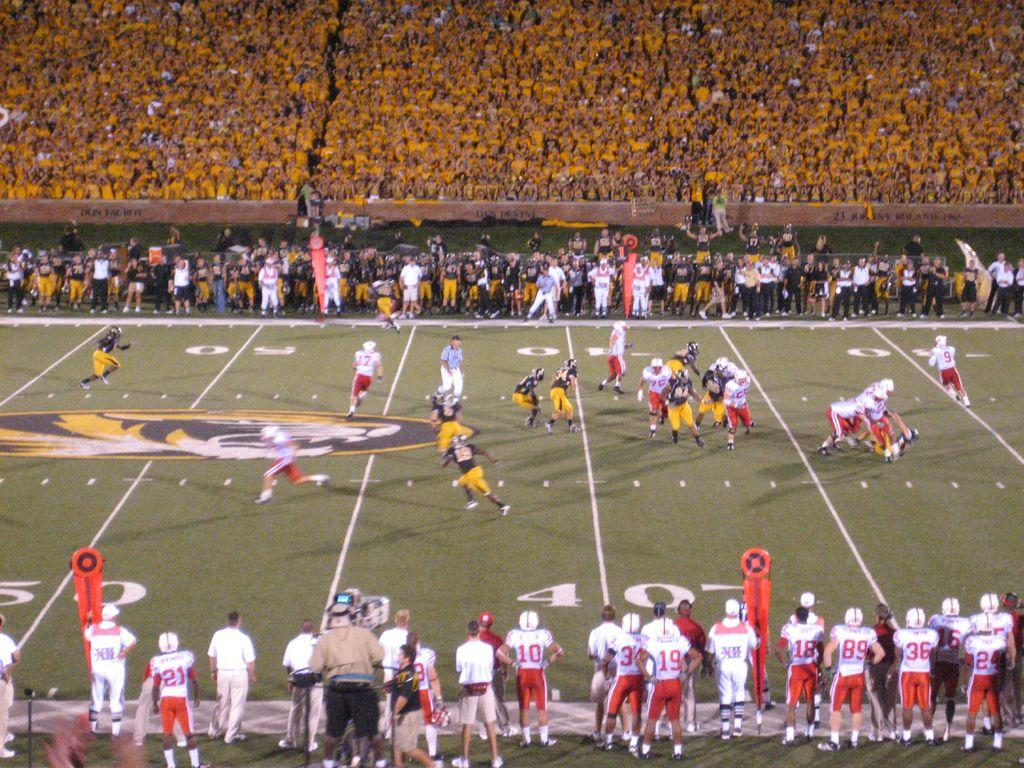What type of structure is visible in the image? There is a stadium in the image. What can be seen happening on the ground in the stadium? There are people on the ground in the stadium. Where are the majority of people located in the stadium? There are people sitting in the stadium. What type of books can be seen stacked on the cow in the image? There is no cow or books present in the image; it features a stadium with people on the ground and sitting. 